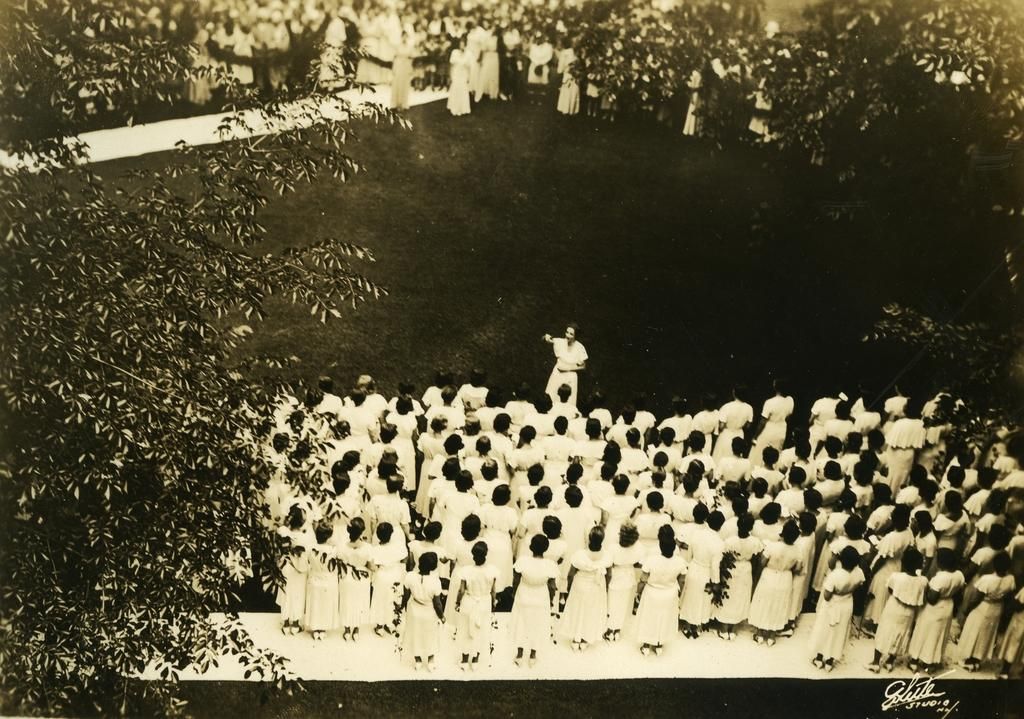What is the color scheme of the image? The image is black and white. What can be seen in the image besides the color scheme? There is a group of people standing on the ground, grass, and trees visible in the image. What type of neck is visible on the trees in the image? There are no necks present on the trees in the image, as trees do not have necks. How long does it take for the minute hand to move in the image? There is no clock or timepiece present in the image, so it is not possible to determine the movement of the minute hand. 